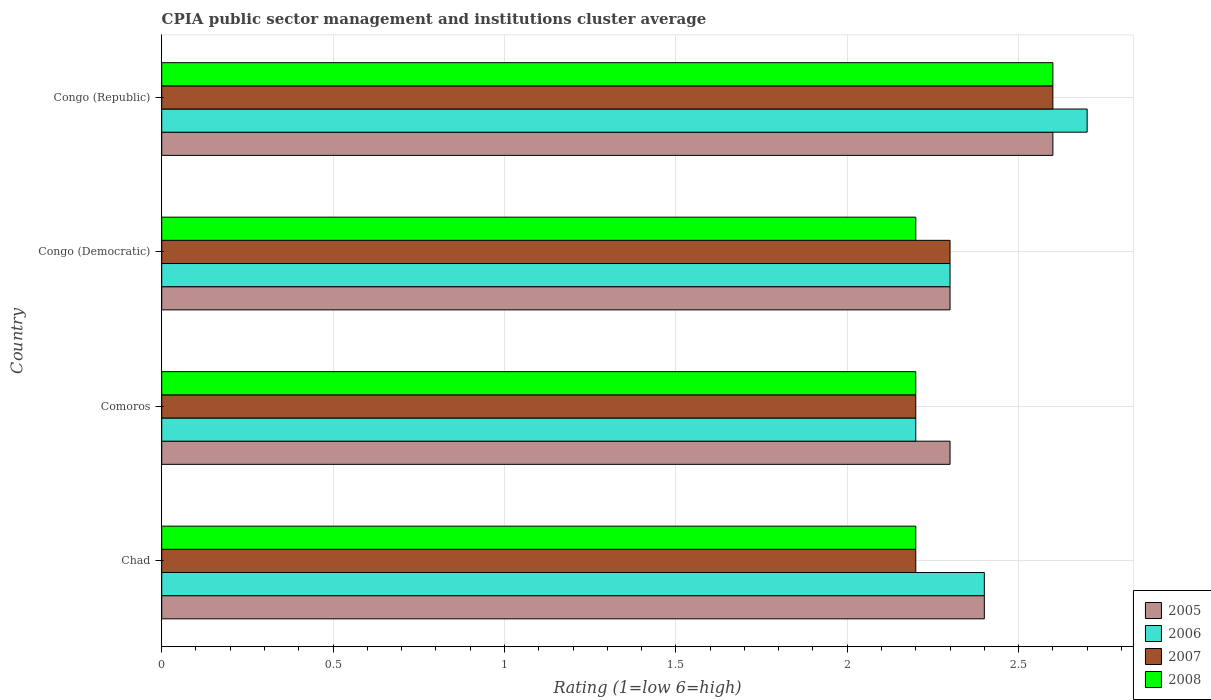Are the number of bars per tick equal to the number of legend labels?
Keep it short and to the point. Yes. Are the number of bars on each tick of the Y-axis equal?
Your answer should be compact. Yes. How many bars are there on the 4th tick from the top?
Keep it short and to the point. 4. How many bars are there on the 1st tick from the bottom?
Ensure brevity in your answer.  4. What is the label of the 1st group of bars from the top?
Provide a succinct answer. Congo (Republic). In how many cases, is the number of bars for a given country not equal to the number of legend labels?
Offer a very short reply. 0. Across all countries, what is the maximum CPIA rating in 2008?
Your answer should be very brief. 2.6. Across all countries, what is the minimum CPIA rating in 2006?
Keep it short and to the point. 2.2. In which country was the CPIA rating in 2007 maximum?
Your answer should be very brief. Congo (Republic). In which country was the CPIA rating in 2008 minimum?
Provide a short and direct response. Chad. What is the total CPIA rating in 2007 in the graph?
Offer a very short reply. 9.3. What is the difference between the CPIA rating in 2006 in Comoros and the CPIA rating in 2008 in Congo (Republic)?
Make the answer very short. -0.4. What is the difference between the CPIA rating in 2005 and CPIA rating in 2006 in Congo (Republic)?
Your answer should be very brief. -0.1. What is the ratio of the CPIA rating in 2005 in Comoros to that in Congo (Republic)?
Offer a very short reply. 0.88. Is the difference between the CPIA rating in 2005 in Chad and Congo (Democratic) greater than the difference between the CPIA rating in 2006 in Chad and Congo (Democratic)?
Ensure brevity in your answer.  No. What is the difference between the highest and the second highest CPIA rating in 2005?
Your answer should be compact. 0.2. What is the difference between the highest and the lowest CPIA rating in 2005?
Offer a very short reply. 0.3. What does the 1st bar from the top in Congo (Democratic) represents?
Give a very brief answer. 2008. What does the 4th bar from the bottom in Congo (Republic) represents?
Give a very brief answer. 2008. Is it the case that in every country, the sum of the CPIA rating in 2007 and CPIA rating in 2005 is greater than the CPIA rating in 2008?
Your response must be concise. Yes. How many bars are there?
Your answer should be very brief. 16. Are all the bars in the graph horizontal?
Your answer should be very brief. Yes. How many countries are there in the graph?
Provide a short and direct response. 4. What is the difference between two consecutive major ticks on the X-axis?
Provide a succinct answer. 0.5. Are the values on the major ticks of X-axis written in scientific E-notation?
Provide a short and direct response. No. Does the graph contain grids?
Keep it short and to the point. Yes. Where does the legend appear in the graph?
Keep it short and to the point. Bottom right. How are the legend labels stacked?
Make the answer very short. Vertical. What is the title of the graph?
Offer a terse response. CPIA public sector management and institutions cluster average. Does "1993" appear as one of the legend labels in the graph?
Your answer should be very brief. No. What is the label or title of the X-axis?
Provide a succinct answer. Rating (1=low 6=high). What is the label or title of the Y-axis?
Keep it short and to the point. Country. What is the Rating (1=low 6=high) in 2007 in Chad?
Offer a terse response. 2.2. What is the Rating (1=low 6=high) in 2005 in Comoros?
Make the answer very short. 2.3. What is the Rating (1=low 6=high) of 2007 in Comoros?
Make the answer very short. 2.2. What is the Rating (1=low 6=high) of 2005 in Congo (Democratic)?
Provide a succinct answer. 2.3. What is the Rating (1=low 6=high) in 2007 in Congo (Democratic)?
Keep it short and to the point. 2.3. Across all countries, what is the maximum Rating (1=low 6=high) of 2007?
Your answer should be very brief. 2.6. Across all countries, what is the maximum Rating (1=low 6=high) in 2008?
Provide a short and direct response. 2.6. Across all countries, what is the minimum Rating (1=low 6=high) in 2005?
Offer a terse response. 2.3. Across all countries, what is the minimum Rating (1=low 6=high) of 2007?
Give a very brief answer. 2.2. Across all countries, what is the minimum Rating (1=low 6=high) in 2008?
Offer a very short reply. 2.2. What is the total Rating (1=low 6=high) in 2006 in the graph?
Offer a very short reply. 9.6. What is the total Rating (1=low 6=high) of 2007 in the graph?
Give a very brief answer. 9.3. What is the difference between the Rating (1=low 6=high) in 2007 in Chad and that in Comoros?
Keep it short and to the point. 0. What is the difference between the Rating (1=low 6=high) in 2008 in Chad and that in Comoros?
Make the answer very short. 0. What is the difference between the Rating (1=low 6=high) of 2005 in Chad and that in Congo (Democratic)?
Your response must be concise. 0.1. What is the difference between the Rating (1=low 6=high) in 2006 in Chad and that in Congo (Democratic)?
Your answer should be very brief. 0.1. What is the difference between the Rating (1=low 6=high) in 2008 in Chad and that in Congo (Democratic)?
Your answer should be very brief. 0. What is the difference between the Rating (1=low 6=high) in 2008 in Chad and that in Congo (Republic)?
Give a very brief answer. -0.4. What is the difference between the Rating (1=low 6=high) of 2005 in Comoros and that in Congo (Democratic)?
Keep it short and to the point. 0. What is the difference between the Rating (1=low 6=high) in 2007 in Comoros and that in Congo (Democratic)?
Provide a succinct answer. -0.1. What is the difference between the Rating (1=low 6=high) of 2005 in Congo (Democratic) and that in Congo (Republic)?
Make the answer very short. -0.3. What is the difference between the Rating (1=low 6=high) in 2006 in Congo (Democratic) and that in Congo (Republic)?
Ensure brevity in your answer.  -0.4. What is the difference between the Rating (1=low 6=high) in 2007 in Congo (Democratic) and that in Congo (Republic)?
Ensure brevity in your answer.  -0.3. What is the difference between the Rating (1=low 6=high) in 2006 in Chad and the Rating (1=low 6=high) in 2007 in Comoros?
Provide a short and direct response. 0.2. What is the difference between the Rating (1=low 6=high) of 2006 in Chad and the Rating (1=low 6=high) of 2008 in Comoros?
Ensure brevity in your answer.  0.2. What is the difference between the Rating (1=low 6=high) in 2005 in Chad and the Rating (1=low 6=high) in 2008 in Congo (Democratic)?
Keep it short and to the point. 0.2. What is the difference between the Rating (1=low 6=high) in 2006 in Chad and the Rating (1=low 6=high) in 2008 in Congo (Democratic)?
Your response must be concise. 0.2. What is the difference between the Rating (1=low 6=high) of 2007 in Chad and the Rating (1=low 6=high) of 2008 in Congo (Democratic)?
Keep it short and to the point. 0. What is the difference between the Rating (1=low 6=high) in 2005 in Chad and the Rating (1=low 6=high) in 2006 in Congo (Republic)?
Your response must be concise. -0.3. What is the difference between the Rating (1=low 6=high) of 2005 in Chad and the Rating (1=low 6=high) of 2008 in Congo (Republic)?
Your response must be concise. -0.2. What is the difference between the Rating (1=low 6=high) of 2006 in Chad and the Rating (1=low 6=high) of 2007 in Congo (Republic)?
Provide a short and direct response. -0.2. What is the difference between the Rating (1=low 6=high) in 2006 in Chad and the Rating (1=low 6=high) in 2008 in Congo (Republic)?
Make the answer very short. -0.2. What is the difference between the Rating (1=low 6=high) of 2005 in Comoros and the Rating (1=low 6=high) of 2006 in Congo (Democratic)?
Ensure brevity in your answer.  0. What is the difference between the Rating (1=low 6=high) of 2005 in Comoros and the Rating (1=low 6=high) of 2006 in Congo (Republic)?
Your answer should be very brief. -0.4. What is the difference between the Rating (1=low 6=high) in 2005 in Comoros and the Rating (1=low 6=high) in 2008 in Congo (Republic)?
Your answer should be compact. -0.3. What is the difference between the Rating (1=low 6=high) of 2006 in Comoros and the Rating (1=low 6=high) of 2007 in Congo (Republic)?
Your response must be concise. -0.4. What is the difference between the Rating (1=low 6=high) of 2007 in Comoros and the Rating (1=low 6=high) of 2008 in Congo (Republic)?
Make the answer very short. -0.4. What is the difference between the Rating (1=low 6=high) in 2005 in Congo (Democratic) and the Rating (1=low 6=high) in 2006 in Congo (Republic)?
Your response must be concise. -0.4. What is the difference between the Rating (1=low 6=high) in 2005 in Congo (Democratic) and the Rating (1=low 6=high) in 2008 in Congo (Republic)?
Your answer should be compact. -0.3. What is the average Rating (1=low 6=high) of 2005 per country?
Give a very brief answer. 2.4. What is the average Rating (1=low 6=high) in 2007 per country?
Offer a terse response. 2.33. What is the difference between the Rating (1=low 6=high) in 2005 and Rating (1=low 6=high) in 2006 in Chad?
Provide a succinct answer. 0. What is the difference between the Rating (1=low 6=high) in 2005 and Rating (1=low 6=high) in 2008 in Chad?
Your answer should be very brief. 0.2. What is the difference between the Rating (1=low 6=high) in 2006 and Rating (1=low 6=high) in 2008 in Chad?
Offer a terse response. 0.2. What is the difference between the Rating (1=low 6=high) in 2005 and Rating (1=low 6=high) in 2006 in Comoros?
Provide a succinct answer. 0.1. What is the difference between the Rating (1=low 6=high) in 2005 and Rating (1=low 6=high) in 2006 in Congo (Democratic)?
Your answer should be very brief. 0. What is the difference between the Rating (1=low 6=high) of 2005 and Rating (1=low 6=high) of 2007 in Congo (Democratic)?
Your answer should be very brief. 0. What is the difference between the Rating (1=low 6=high) of 2006 and Rating (1=low 6=high) of 2007 in Congo (Democratic)?
Your response must be concise. 0. What is the difference between the Rating (1=low 6=high) of 2007 and Rating (1=low 6=high) of 2008 in Congo (Democratic)?
Your response must be concise. 0.1. What is the difference between the Rating (1=low 6=high) in 2005 and Rating (1=low 6=high) in 2006 in Congo (Republic)?
Provide a succinct answer. -0.1. What is the difference between the Rating (1=low 6=high) of 2005 and Rating (1=low 6=high) of 2007 in Congo (Republic)?
Provide a short and direct response. 0. What is the difference between the Rating (1=low 6=high) in 2005 and Rating (1=low 6=high) in 2008 in Congo (Republic)?
Provide a succinct answer. 0. What is the difference between the Rating (1=low 6=high) of 2006 and Rating (1=low 6=high) of 2008 in Congo (Republic)?
Offer a terse response. 0.1. What is the ratio of the Rating (1=low 6=high) in 2005 in Chad to that in Comoros?
Keep it short and to the point. 1.04. What is the ratio of the Rating (1=low 6=high) in 2008 in Chad to that in Comoros?
Ensure brevity in your answer.  1. What is the ratio of the Rating (1=low 6=high) in 2005 in Chad to that in Congo (Democratic)?
Offer a very short reply. 1.04. What is the ratio of the Rating (1=low 6=high) of 2006 in Chad to that in Congo (Democratic)?
Ensure brevity in your answer.  1.04. What is the ratio of the Rating (1=low 6=high) in 2007 in Chad to that in Congo (Democratic)?
Provide a short and direct response. 0.96. What is the ratio of the Rating (1=low 6=high) in 2008 in Chad to that in Congo (Democratic)?
Your response must be concise. 1. What is the ratio of the Rating (1=low 6=high) of 2005 in Chad to that in Congo (Republic)?
Your answer should be very brief. 0.92. What is the ratio of the Rating (1=low 6=high) of 2007 in Chad to that in Congo (Republic)?
Keep it short and to the point. 0.85. What is the ratio of the Rating (1=low 6=high) in 2008 in Chad to that in Congo (Republic)?
Give a very brief answer. 0.85. What is the ratio of the Rating (1=low 6=high) in 2006 in Comoros to that in Congo (Democratic)?
Your response must be concise. 0.96. What is the ratio of the Rating (1=low 6=high) in 2007 in Comoros to that in Congo (Democratic)?
Provide a short and direct response. 0.96. What is the ratio of the Rating (1=low 6=high) of 2005 in Comoros to that in Congo (Republic)?
Offer a terse response. 0.88. What is the ratio of the Rating (1=low 6=high) of 2006 in Comoros to that in Congo (Republic)?
Provide a succinct answer. 0.81. What is the ratio of the Rating (1=low 6=high) of 2007 in Comoros to that in Congo (Republic)?
Offer a terse response. 0.85. What is the ratio of the Rating (1=low 6=high) of 2008 in Comoros to that in Congo (Republic)?
Offer a very short reply. 0.85. What is the ratio of the Rating (1=low 6=high) in 2005 in Congo (Democratic) to that in Congo (Republic)?
Offer a very short reply. 0.88. What is the ratio of the Rating (1=low 6=high) in 2006 in Congo (Democratic) to that in Congo (Republic)?
Provide a succinct answer. 0.85. What is the ratio of the Rating (1=low 6=high) in 2007 in Congo (Democratic) to that in Congo (Republic)?
Ensure brevity in your answer.  0.88. What is the ratio of the Rating (1=low 6=high) of 2008 in Congo (Democratic) to that in Congo (Republic)?
Keep it short and to the point. 0.85. What is the difference between the highest and the second highest Rating (1=low 6=high) in 2006?
Keep it short and to the point. 0.3. What is the difference between the highest and the second highest Rating (1=low 6=high) in 2008?
Give a very brief answer. 0.4. What is the difference between the highest and the lowest Rating (1=low 6=high) of 2008?
Offer a very short reply. 0.4. 